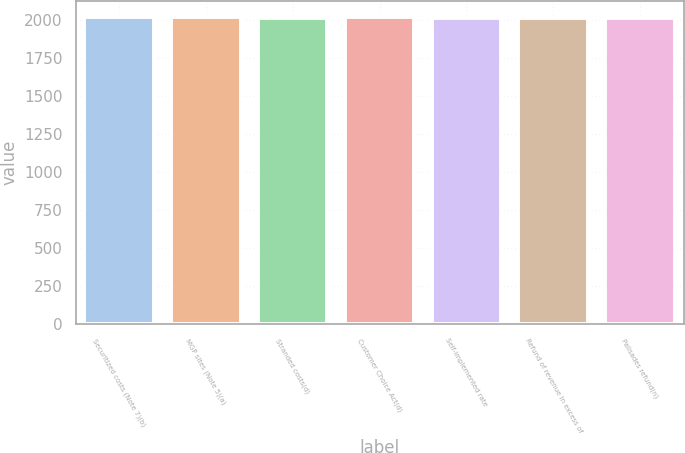Convert chart to OTSL. <chart><loc_0><loc_0><loc_500><loc_500><bar_chart><fcel>Securitized costs (Note 7)(b)<fcel>MGP sites (Note 5)(a)<fcel>Stranded costs(d)<fcel>Customer Choice Act(d)<fcel>Self-implemented rate<fcel>Refund of revenue in excess of<fcel>Palisades refund(n)<nl><fcel>2015.5<fcel>2020<fcel>2013.7<fcel>2014.6<fcel>2011<fcel>2011.9<fcel>2012.8<nl></chart> 